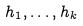Convert formula to latex. <formula><loc_0><loc_0><loc_500><loc_500>h _ { 1 } , \dots , h _ { k }</formula> 